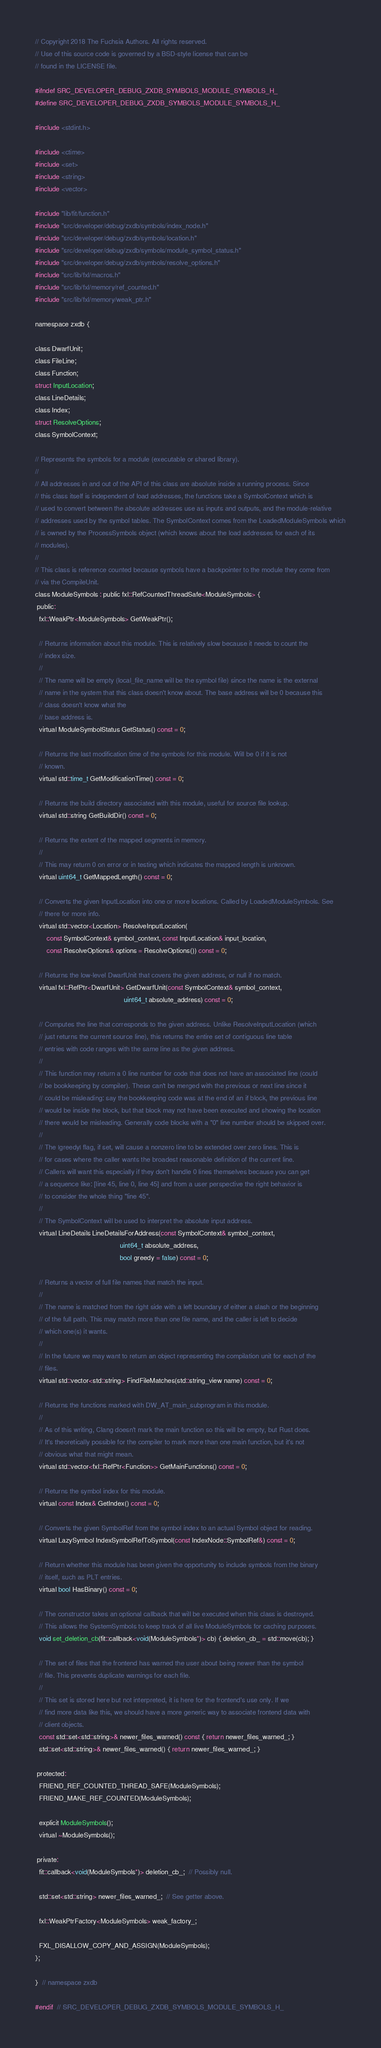<code> <loc_0><loc_0><loc_500><loc_500><_C_>// Copyright 2018 The Fuchsia Authors. All rights reserved.
// Use of this source code is governed by a BSD-style license that can be
// found in the LICENSE file.

#ifndef SRC_DEVELOPER_DEBUG_ZXDB_SYMBOLS_MODULE_SYMBOLS_H_
#define SRC_DEVELOPER_DEBUG_ZXDB_SYMBOLS_MODULE_SYMBOLS_H_

#include <stdint.h>

#include <ctime>
#include <set>
#include <string>
#include <vector>

#include "lib/fit/function.h"
#include "src/developer/debug/zxdb/symbols/index_node.h"
#include "src/developer/debug/zxdb/symbols/location.h"
#include "src/developer/debug/zxdb/symbols/module_symbol_status.h"
#include "src/developer/debug/zxdb/symbols/resolve_options.h"
#include "src/lib/fxl/macros.h"
#include "src/lib/fxl/memory/ref_counted.h"
#include "src/lib/fxl/memory/weak_ptr.h"

namespace zxdb {

class DwarfUnit;
class FileLine;
class Function;
struct InputLocation;
class LineDetails;
class Index;
struct ResolveOptions;
class SymbolContext;

// Represents the symbols for a module (executable or shared library).
//
// All addresses in and out of the API of this class are absolute inside a running process. Since
// this class itself is independent of load addresses, the functions take a SymbolContext which is
// used to convert between the absolute addresses use as inputs and outputs, and the module-relative
// addresses used by the symbol tables. The SymbolContext comes from the LoadedModuleSymbols which
// is owned by the ProcessSymbols object (which knows about the load addresses for each of its
// modules).
//
// This class is reference counted because symbols have a backpointer to the module they come from
// via the CompileUnit.
class ModuleSymbols : public fxl::RefCountedThreadSafe<ModuleSymbols> {
 public:
  fxl::WeakPtr<ModuleSymbols> GetWeakPtr();

  // Returns information about this module. This is relatively slow because it needs to count the
  // index size.
  //
  // The name will be empty (local_file_name will be the symbol file) since the name is the external
  // name in the system that this class doesn't know about. The base address will be 0 because this
  // class doesn't know what the
  // base address is.
  virtual ModuleSymbolStatus GetStatus() const = 0;

  // Returns the last modification time of the symbols for this module. Will be 0 if it is not
  // known.
  virtual std::time_t GetModificationTime() const = 0;

  // Returns the build directory associated with this module, useful for source file lookup.
  virtual std::string GetBuildDir() const = 0;

  // Returns the extent of the mapped segments in memory.
  //
  // This may return 0 on error or in testing which indicates the mapped length is unknown.
  virtual uint64_t GetMappedLength() const = 0;

  // Converts the given InputLocation into one or more locations. Called by LoadedModuleSymbols. See
  // there for more info.
  virtual std::vector<Location> ResolveInputLocation(
      const SymbolContext& symbol_context, const InputLocation& input_location,
      const ResolveOptions& options = ResolveOptions()) const = 0;

  // Returns the low-level DwarfUnit that covers the given address, or null if no match.
  virtual fxl::RefPtr<DwarfUnit> GetDwarfUnit(const SymbolContext& symbol_context,
                                              uint64_t absolute_address) const = 0;

  // Computes the line that corresponds to the given address. Unlike ResolveInputLocation (which
  // just returns the current source line), this returns the entire set of contiguous line table
  // entries with code ranges with the same line as the given address.
  //
  // This function may return a 0 line number for code that does not have an associated line (could
  // be bookkeeping by compiler). These can't be merged with the previous or next line since it
  // could be misleading: say the bookkeeping code was at the end of an if block, the previous line
  // would be inside the block, but that block may not have been executed and showing the location
  // there would be misleading. Generally code blocks with a "0" line number should be skipped over.
  //
  // The |greedy| flag, if set, will cause a nonzero line to be extended over zero lines. This is
  // for cases where the caller wants the broadest reasonable definition of the current line.
  // Callers will want this especially if they don't handle 0 lines themselves because you can get
  // a sequence like: [line 45, line 0, line 45] and from a user perspective the right behavior is
  // to consider the whole thing "line 45".
  //
  // The SymbolContext will be used to interpret the absolute input address.
  virtual LineDetails LineDetailsForAddress(const SymbolContext& symbol_context,
                                            uint64_t absolute_address,
                                            bool greedy = false) const = 0;

  // Returns a vector of full file names that match the input.
  //
  // The name is matched from the right side with a left boundary of either a slash or the beginning
  // of the full path. This may match more than one file name, and the caller is left to decide
  // which one(s) it wants.
  //
  // In the future we may want to return an object representing the compilation unit for each of the
  // files.
  virtual std::vector<std::string> FindFileMatches(std::string_view name) const = 0;

  // Returns the functions marked with DW_AT_main_subprogram in this module.
  //
  // As of this writing, Clang doesn't mark the main function so this will be empty, but Rust does.
  // It's theoretically possible for the compiler to mark more than one main function, but it's not
  // obvious what that might mean.
  virtual std::vector<fxl::RefPtr<Function>> GetMainFunctions() const = 0;

  // Returns the symbol index for this module.
  virtual const Index& GetIndex() const = 0;

  // Converts the given SymbolRef from the symbol index to an actual Symbol object for reading.
  virtual LazySymbol IndexSymbolRefToSymbol(const IndexNode::SymbolRef&) const = 0;

  // Return whether this module has been given the opportunity to include symbols from the binary
  // itself, such as PLT entries.
  virtual bool HasBinary() const = 0;

  // The constructor takes an optional callback that will be executed when this class is destroyed.
  // This allows the SystemSymbols to keep track of all live ModuleSymbols for caching purposes.
  void set_deletion_cb(fit::callback<void(ModuleSymbols*)> cb) { deletion_cb_ = std::move(cb); }

  // The set of files that the frontend has warned the user about being newer than the symbol
  // file. This prevents duplicate warnings for each file.
  //
  // This set is stored here but not interpreted, it is here for the frontend's use only. If we
  // find more data like this, we should have a more generic way to associate frontend data with
  // client objects.
  const std::set<std::string>& newer_files_warned() const { return newer_files_warned_; }
  std::set<std::string>& newer_files_warned() { return newer_files_warned_; }

 protected:
  FRIEND_REF_COUNTED_THREAD_SAFE(ModuleSymbols);
  FRIEND_MAKE_REF_COUNTED(ModuleSymbols);

  explicit ModuleSymbols();
  virtual ~ModuleSymbols();

 private:
  fit::callback<void(ModuleSymbols*)> deletion_cb_;  // Possibly null.

  std::set<std::string> newer_files_warned_;  // See getter above.

  fxl::WeakPtrFactory<ModuleSymbols> weak_factory_;

  FXL_DISALLOW_COPY_AND_ASSIGN(ModuleSymbols);
};

}  // namespace zxdb

#endif  // SRC_DEVELOPER_DEBUG_ZXDB_SYMBOLS_MODULE_SYMBOLS_H_
</code> 